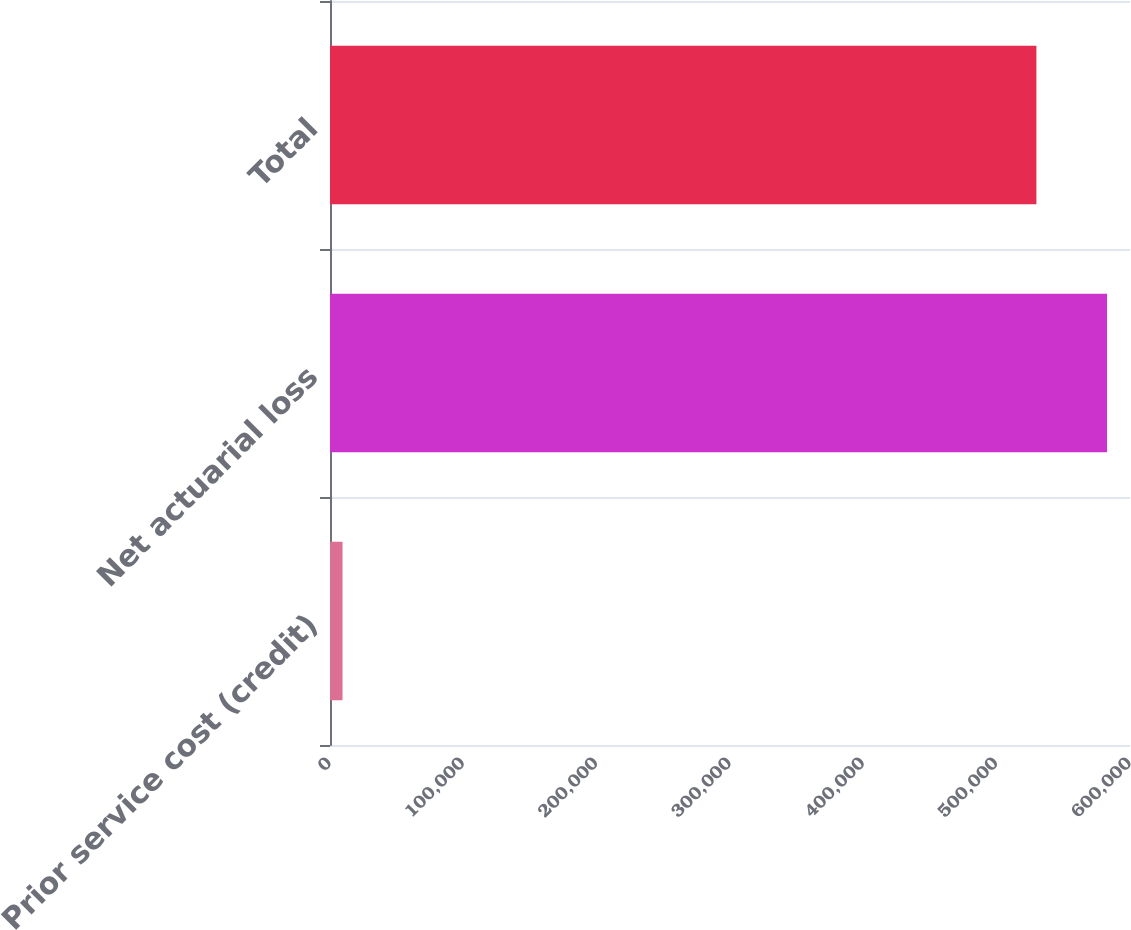Convert chart to OTSL. <chart><loc_0><loc_0><loc_500><loc_500><bar_chart><fcel>Prior service cost (credit)<fcel>Net actuarial loss<fcel>Total<nl><fcel>9385<fcel>582783<fcel>529803<nl></chart> 